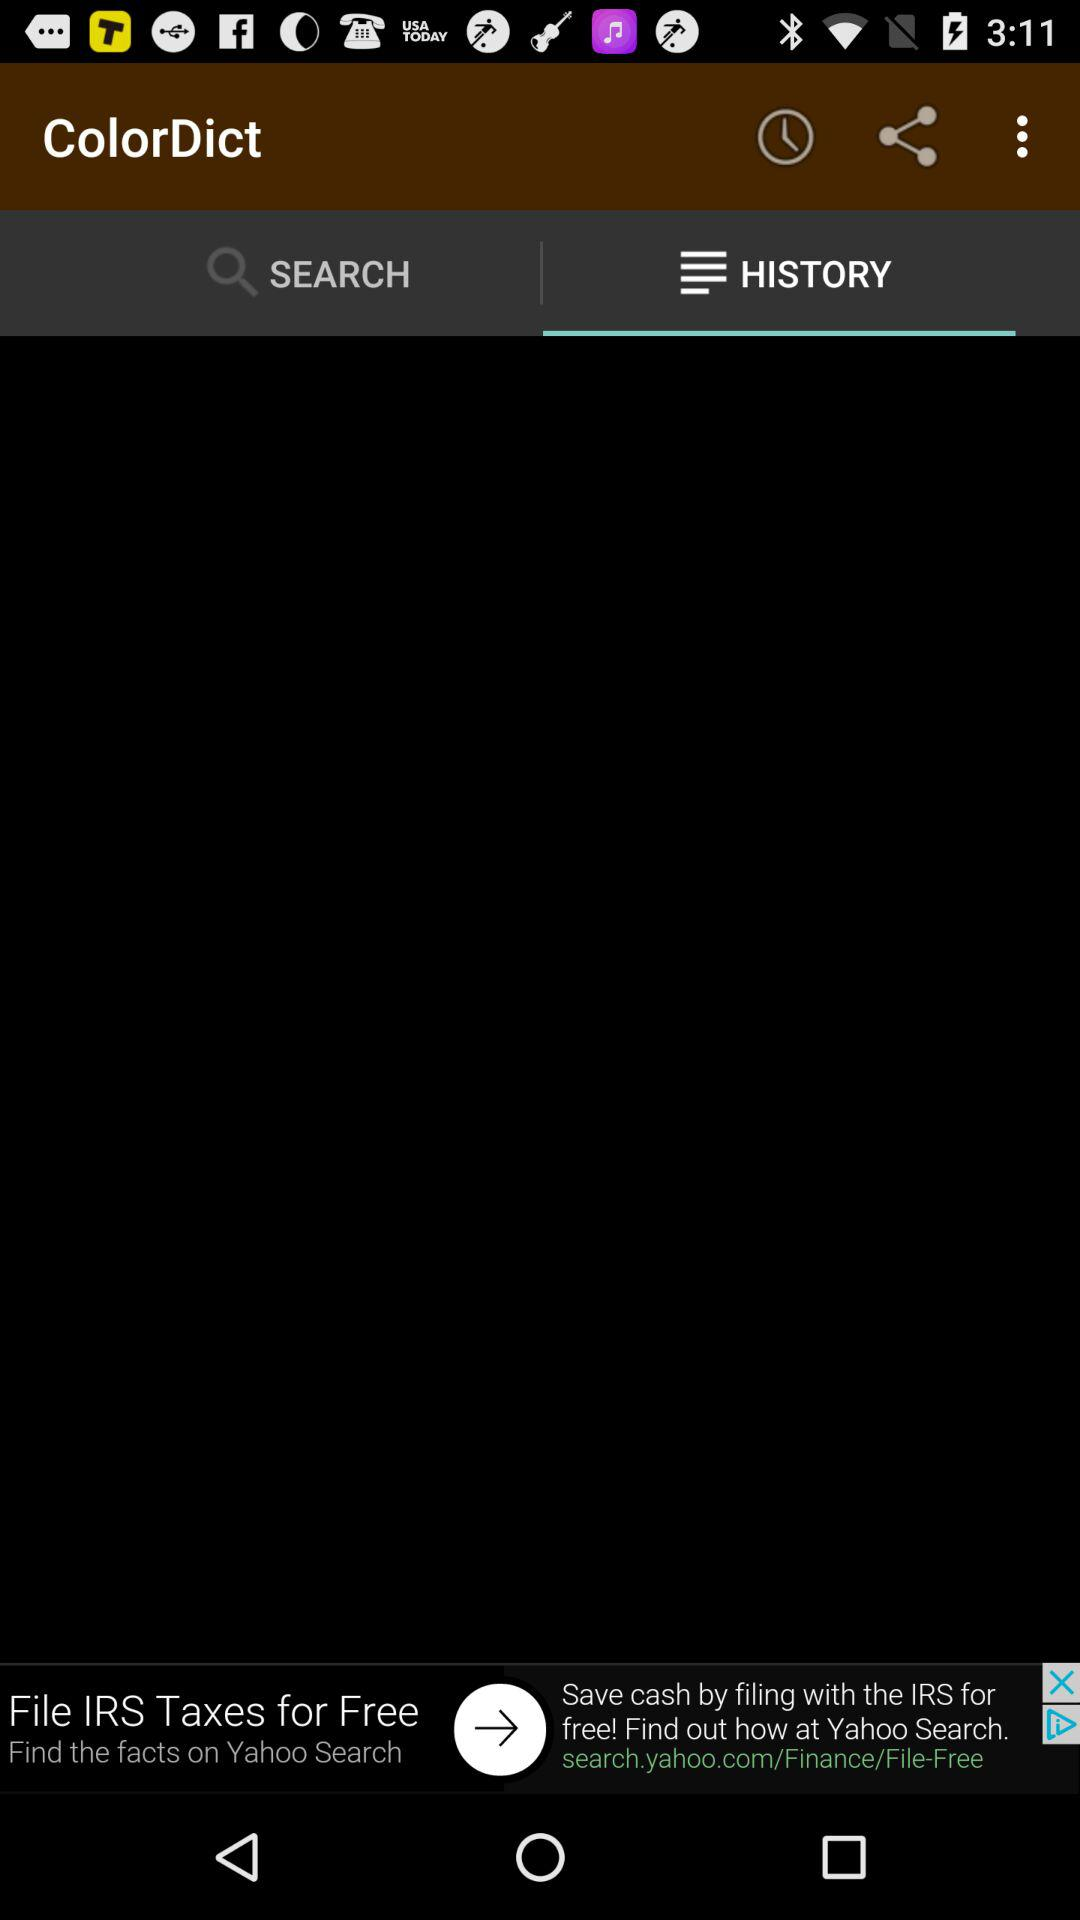Which tab is selected? The selected tab is "HISTORY". 